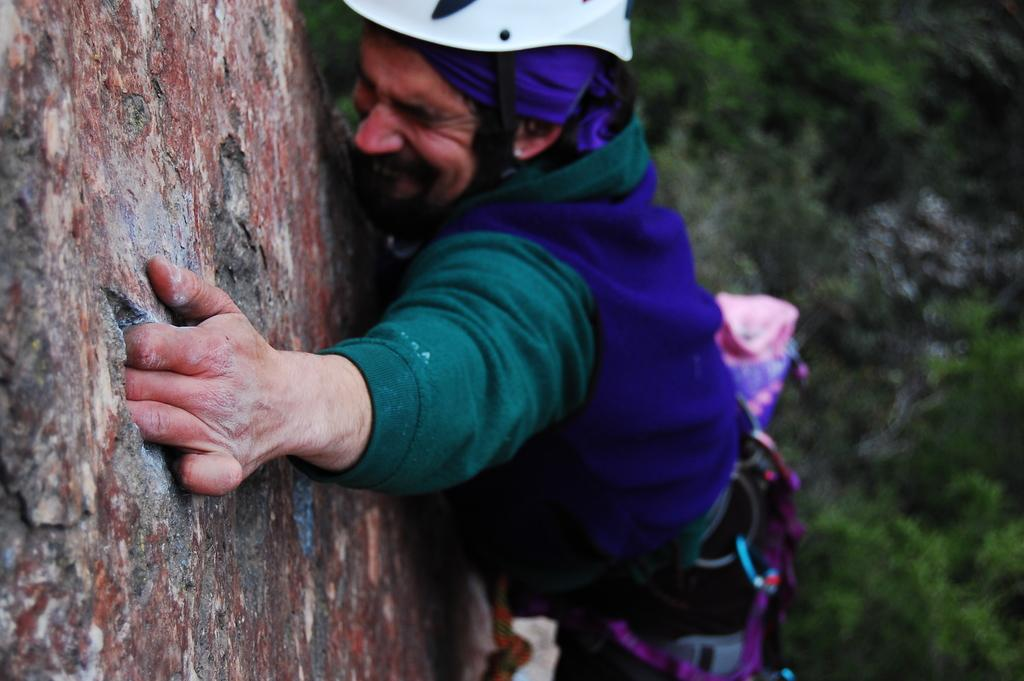Who is present in the image? There is a person in the image. What is the person doing in the image? The person is doing hill climbing in the image. What can be seen in the background of the image? There are trees on both the left and right sides of the image. What type of representative can be seen in the image? There is no representative present in the image; it features a person hill climbing. How many ants can be seen on the person's shoes in the image? There are no ants visible in the image. 